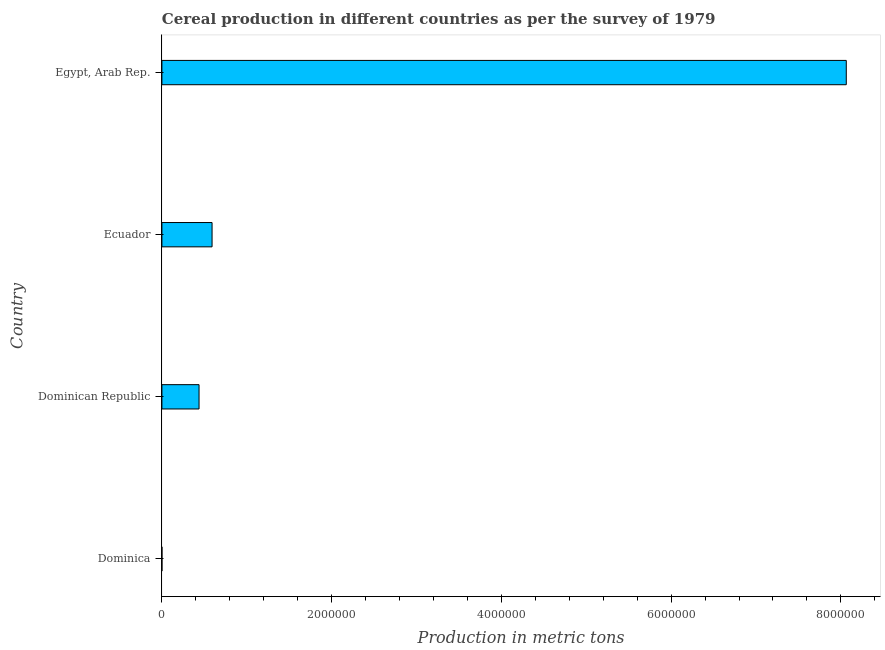Does the graph contain any zero values?
Make the answer very short. No. Does the graph contain grids?
Ensure brevity in your answer.  No. What is the title of the graph?
Keep it short and to the point. Cereal production in different countries as per the survey of 1979. What is the label or title of the X-axis?
Provide a succinct answer. Production in metric tons. What is the cereal production in Dominican Republic?
Your answer should be very brief. 4.38e+05. Across all countries, what is the maximum cereal production?
Offer a terse response. 8.06e+06. Across all countries, what is the minimum cereal production?
Offer a very short reply. 220. In which country was the cereal production maximum?
Offer a very short reply. Egypt, Arab Rep. In which country was the cereal production minimum?
Offer a very short reply. Dominica. What is the sum of the cereal production?
Keep it short and to the point. 9.09e+06. What is the difference between the cereal production in Dominica and Ecuador?
Offer a terse response. -5.91e+05. What is the average cereal production per country?
Make the answer very short. 2.27e+06. What is the median cereal production?
Ensure brevity in your answer.  5.14e+05. In how many countries, is the cereal production greater than 3600000 metric tons?
Make the answer very short. 1. What is the ratio of the cereal production in Dominican Republic to that in Egypt, Arab Rep.?
Your response must be concise. 0.05. What is the difference between the highest and the second highest cereal production?
Ensure brevity in your answer.  7.47e+06. What is the difference between the highest and the lowest cereal production?
Provide a short and direct response. 8.06e+06. In how many countries, is the cereal production greater than the average cereal production taken over all countries?
Your response must be concise. 1. Are all the bars in the graph horizontal?
Provide a short and direct response. Yes. What is the Production in metric tons in Dominica?
Your answer should be compact. 220. What is the Production in metric tons in Dominican Republic?
Make the answer very short. 4.38e+05. What is the Production in metric tons in Ecuador?
Keep it short and to the point. 5.91e+05. What is the Production in metric tons of Egypt, Arab Rep.?
Ensure brevity in your answer.  8.06e+06. What is the difference between the Production in metric tons in Dominica and Dominican Republic?
Provide a succinct answer. -4.37e+05. What is the difference between the Production in metric tons in Dominica and Ecuador?
Your answer should be compact. -5.91e+05. What is the difference between the Production in metric tons in Dominica and Egypt, Arab Rep.?
Provide a succinct answer. -8.06e+06. What is the difference between the Production in metric tons in Dominican Republic and Ecuador?
Give a very brief answer. -1.53e+05. What is the difference between the Production in metric tons in Dominican Republic and Egypt, Arab Rep.?
Give a very brief answer. -7.63e+06. What is the difference between the Production in metric tons in Ecuador and Egypt, Arab Rep.?
Provide a succinct answer. -7.47e+06. What is the ratio of the Production in metric tons in Dominica to that in Dominican Republic?
Ensure brevity in your answer.  0. What is the ratio of the Production in metric tons in Dominica to that in Ecuador?
Offer a very short reply. 0. What is the ratio of the Production in metric tons in Dominica to that in Egypt, Arab Rep.?
Give a very brief answer. 0. What is the ratio of the Production in metric tons in Dominican Republic to that in Ecuador?
Give a very brief answer. 0.74. What is the ratio of the Production in metric tons in Dominican Republic to that in Egypt, Arab Rep.?
Your response must be concise. 0.05. What is the ratio of the Production in metric tons in Ecuador to that in Egypt, Arab Rep.?
Make the answer very short. 0.07. 